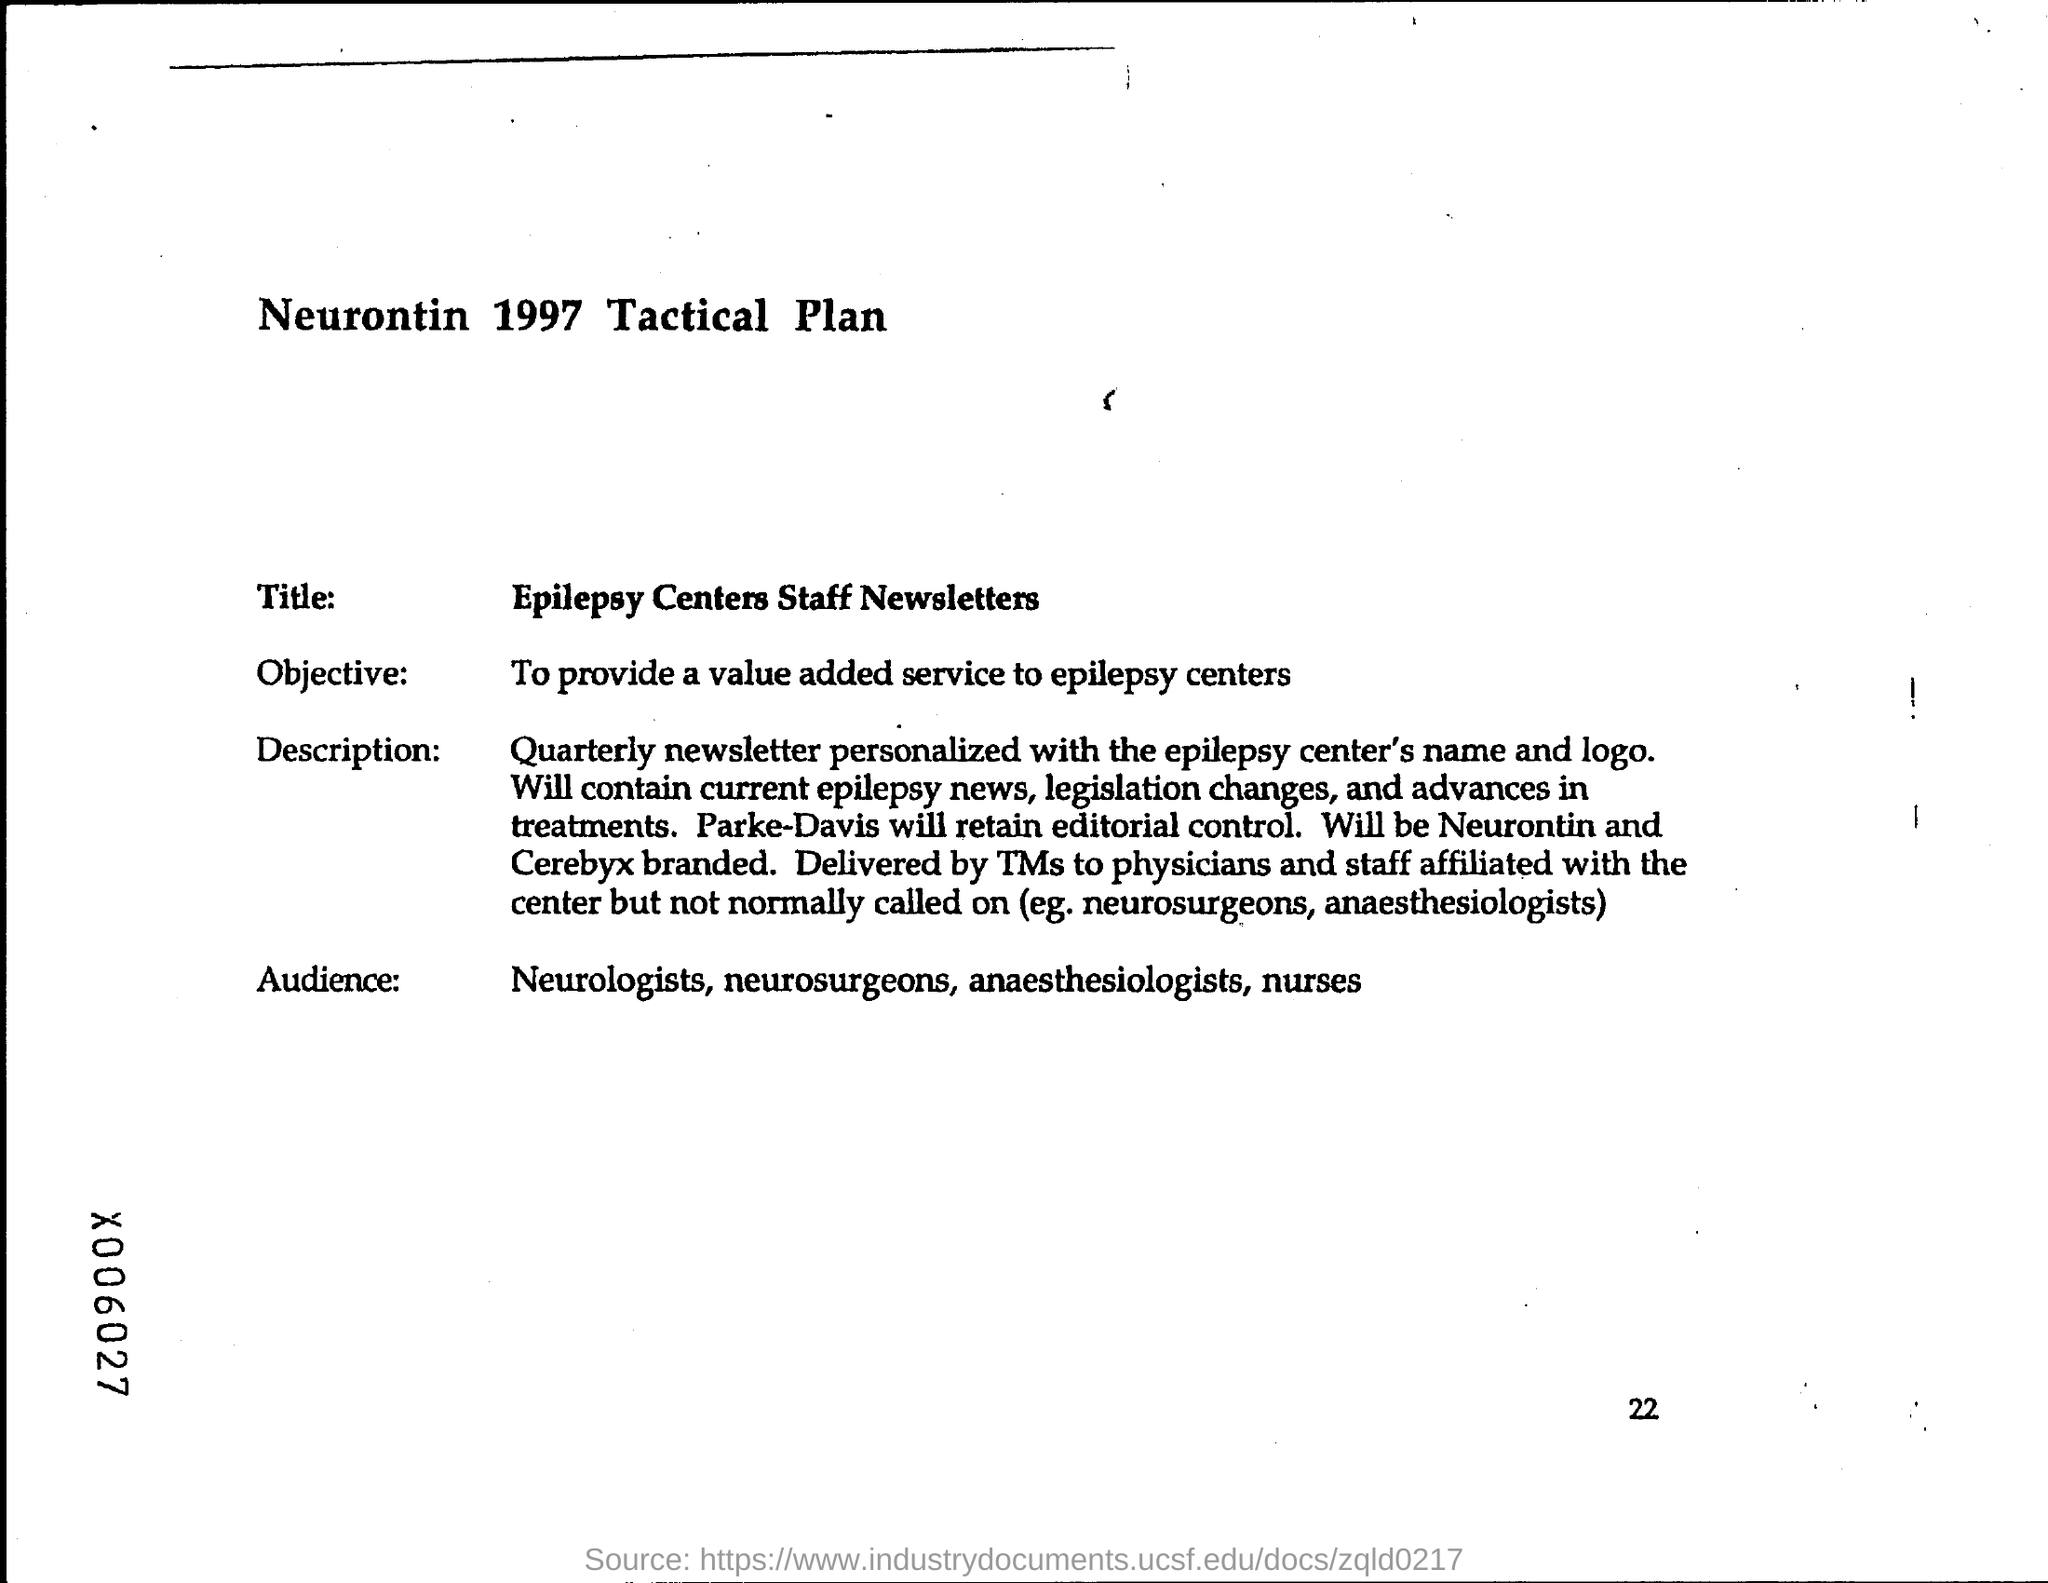Indicate a few pertinent items in this graphic. The page number at the bottom of the page is 22. The objective is to provide a value-added service to epilepsy centers. The title of this text is "What is Epilepsy?", and it provides information about the condition for patients, staff, and those interested in learning about the topic. The document also includes newsletters and information for centers. 